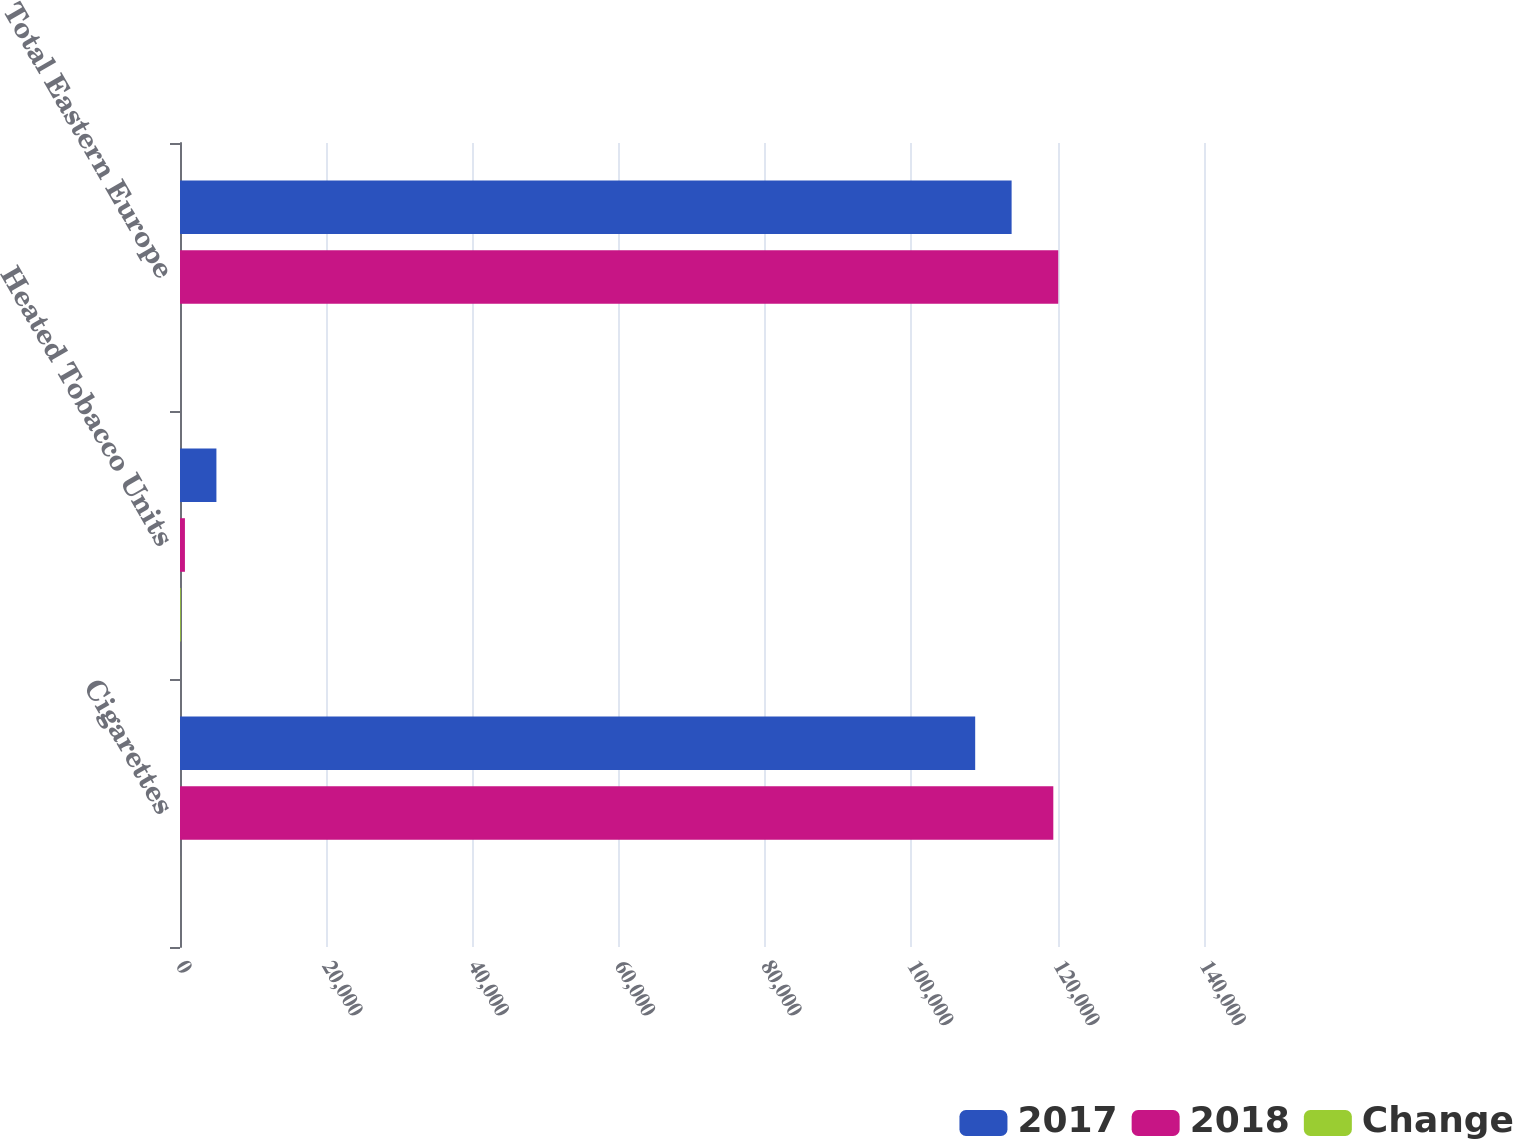Convert chart. <chart><loc_0><loc_0><loc_500><loc_500><stacked_bar_chart><ecel><fcel>Cigarettes<fcel>Heated Tobacco Units<fcel>Total Eastern Europe<nl><fcel>2017<fcel>108718<fcel>4979<fcel>113697<nl><fcel>2018<fcel>119398<fcel>674<fcel>120072<nl><fcel>Change<fcel>8.9<fcel>100<fcel>5.3<nl></chart> 